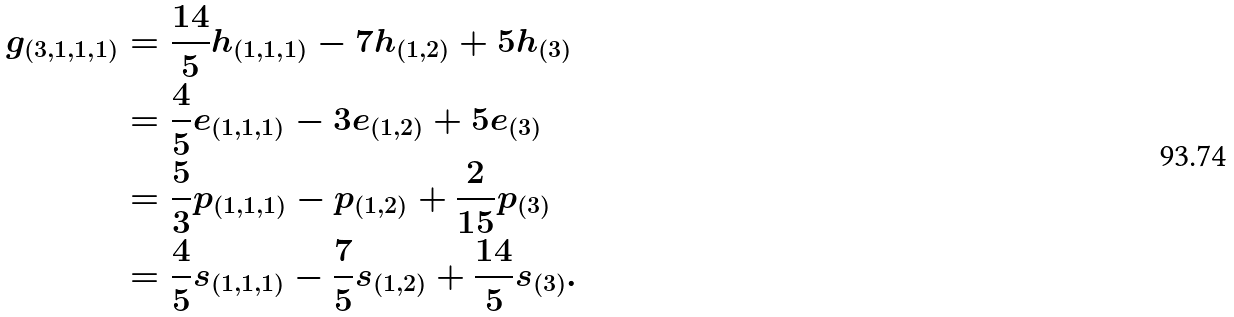Convert formula to latex. <formula><loc_0><loc_0><loc_500><loc_500>g _ { ( 3 , 1 , 1 , 1 ) } & = \frac { 1 4 } { 5 } h _ { ( 1 , 1 , 1 ) } - 7 h _ { ( 1 , 2 ) } + 5 h _ { ( 3 ) } \\ & = \frac { 4 } { 5 } e _ { ( 1 , 1 , 1 ) } - 3 e _ { ( 1 , 2 ) } + 5 e _ { ( 3 ) } \\ & = \frac { 5 } { 3 } p _ { ( 1 , 1 , 1 ) } - p _ { ( 1 , 2 ) } + \frac { 2 } { 1 5 } p _ { ( 3 ) } \\ & = \frac { 4 } { 5 } s _ { ( 1 , 1 , 1 ) } - \frac { 7 } { 5 } s _ { ( 1 , 2 ) } + \frac { 1 4 } { 5 } s _ { ( 3 ) } .</formula> 